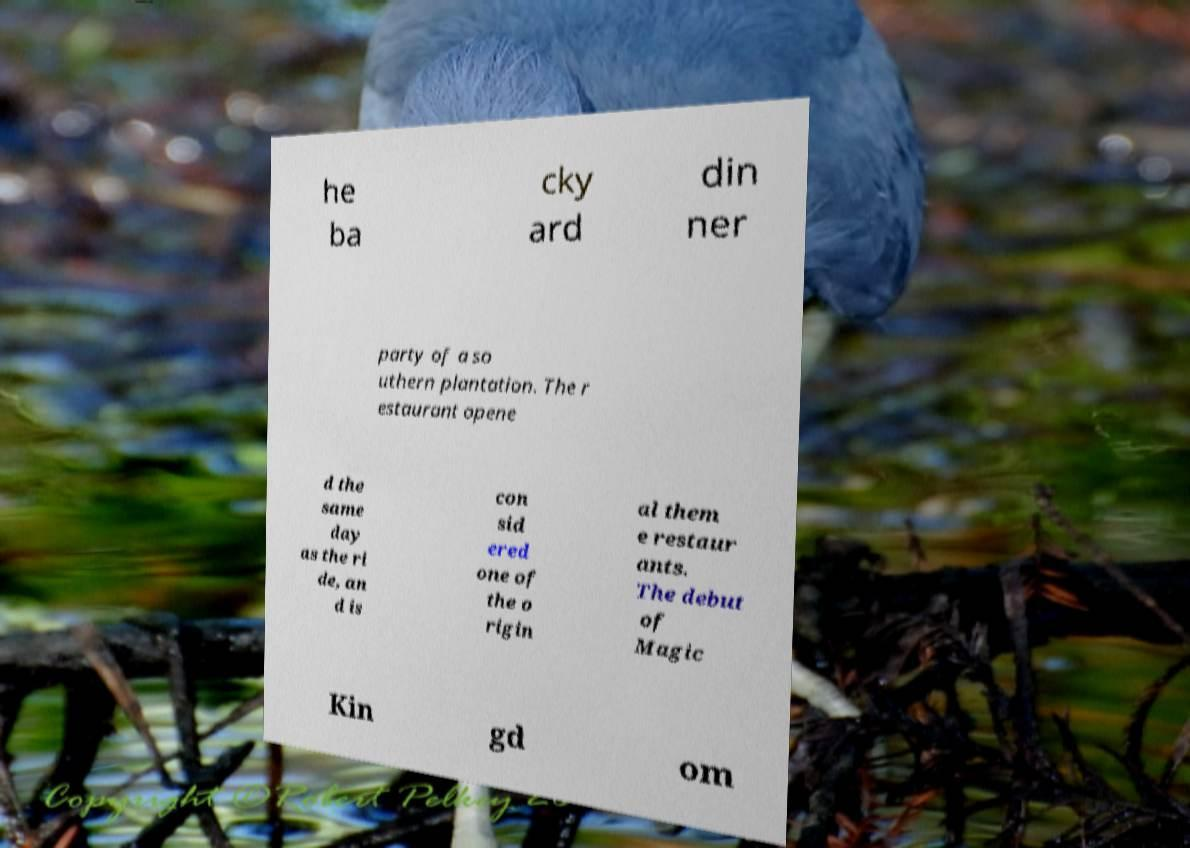What messages or text are displayed in this image? I need them in a readable, typed format. he ba cky ard din ner party of a so uthern plantation. The r estaurant opene d the same day as the ri de, an d is con sid ered one of the o rigin al them e restaur ants. The debut of Magic Kin gd om 